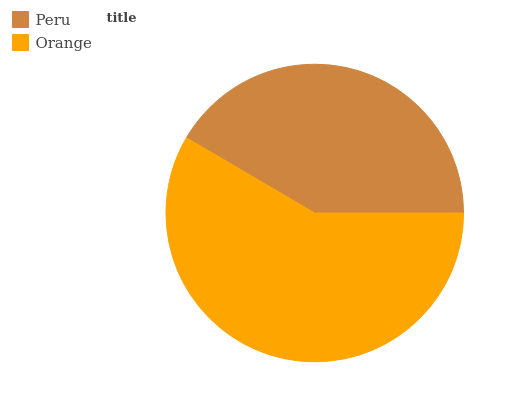Is Peru the minimum?
Answer yes or no. Yes. Is Orange the maximum?
Answer yes or no. Yes. Is Orange the minimum?
Answer yes or no. No. Is Orange greater than Peru?
Answer yes or no. Yes. Is Peru less than Orange?
Answer yes or no. Yes. Is Peru greater than Orange?
Answer yes or no. No. Is Orange less than Peru?
Answer yes or no. No. Is Orange the high median?
Answer yes or no. Yes. Is Peru the low median?
Answer yes or no. Yes. Is Peru the high median?
Answer yes or no. No. Is Orange the low median?
Answer yes or no. No. 